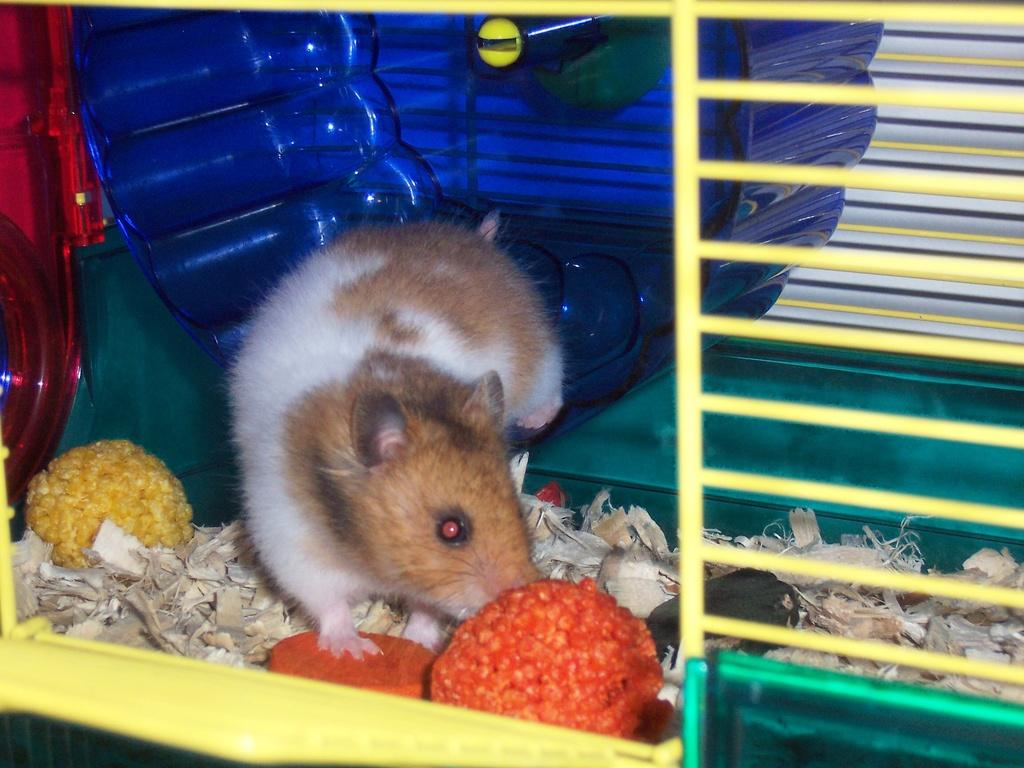What is the main subject of the image? There is a rat in a cage in the image. What is inside the cage with the rat? The rat has food items and wood pieces in the cage. Can you describe the object visible in the background of the image? Unfortunately, the facts provided do not give any information about the object in the background. What type of jam is the rat eating in the image? There is no jam present in the image; the rat has food items and wood pieces in the cage. How does the rat's digestion system work in the image? The facts provided do not give any information about the rat's digestion system, so we cannot answer this question. 